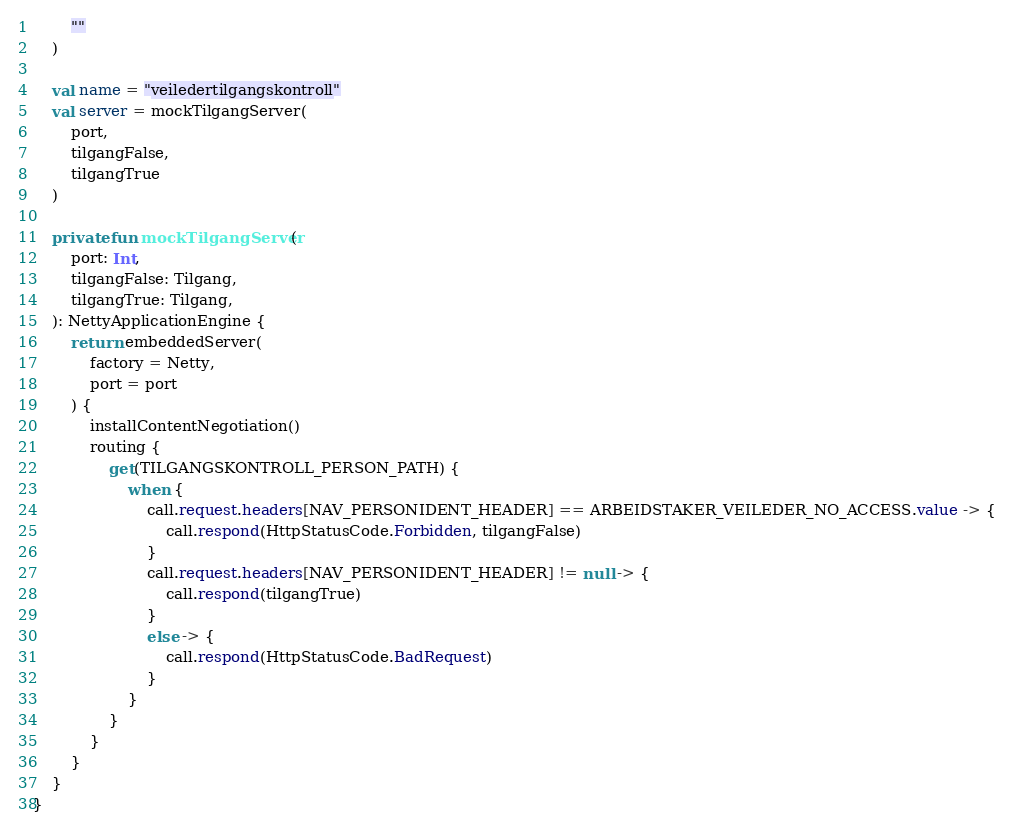<code> <loc_0><loc_0><loc_500><loc_500><_Kotlin_>        ""
    )

    val name = "veiledertilgangskontroll"
    val server = mockTilgangServer(
        port,
        tilgangFalse,
        tilgangTrue
    )

    private fun mockTilgangServer(
        port: Int,
        tilgangFalse: Tilgang,
        tilgangTrue: Tilgang,
    ): NettyApplicationEngine {
        return embeddedServer(
            factory = Netty,
            port = port
        ) {
            installContentNegotiation()
            routing {
                get(TILGANGSKONTROLL_PERSON_PATH) {
                    when {
                        call.request.headers[NAV_PERSONIDENT_HEADER] == ARBEIDSTAKER_VEILEDER_NO_ACCESS.value -> {
                            call.respond(HttpStatusCode.Forbidden, tilgangFalse)
                        }
                        call.request.headers[NAV_PERSONIDENT_HEADER] != null -> {
                            call.respond(tilgangTrue)
                        }
                        else -> {
                            call.respond(HttpStatusCode.BadRequest)
                        }
                    }
                }
            }
        }
    }
}
</code> 